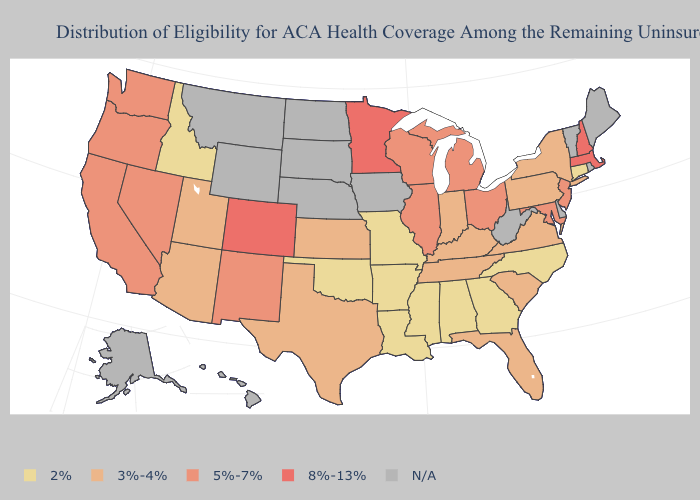What is the highest value in states that border Maine?
Answer briefly. 8%-13%. What is the lowest value in states that border South Dakota?
Be succinct. 8%-13%. How many symbols are there in the legend?
Quick response, please. 5. Name the states that have a value in the range 3%-4%?
Be succinct. Arizona, Florida, Indiana, Kansas, Kentucky, New York, Pennsylvania, South Carolina, Tennessee, Texas, Utah, Virginia. How many symbols are there in the legend?
Concise answer only. 5. Name the states that have a value in the range 5%-7%?
Concise answer only. California, Illinois, Maryland, Michigan, Nevada, New Jersey, New Mexico, Ohio, Oregon, Washington, Wisconsin. What is the value of Louisiana?
Answer briefly. 2%. What is the value of South Dakota?
Keep it brief. N/A. What is the value of Georgia?
Keep it brief. 2%. Among the states that border Arizona , does Colorado have the highest value?
Write a very short answer. Yes. What is the highest value in the South ?
Be succinct. 5%-7%. Does the map have missing data?
Write a very short answer. Yes. Does Wisconsin have the lowest value in the USA?
Quick response, please. No. 